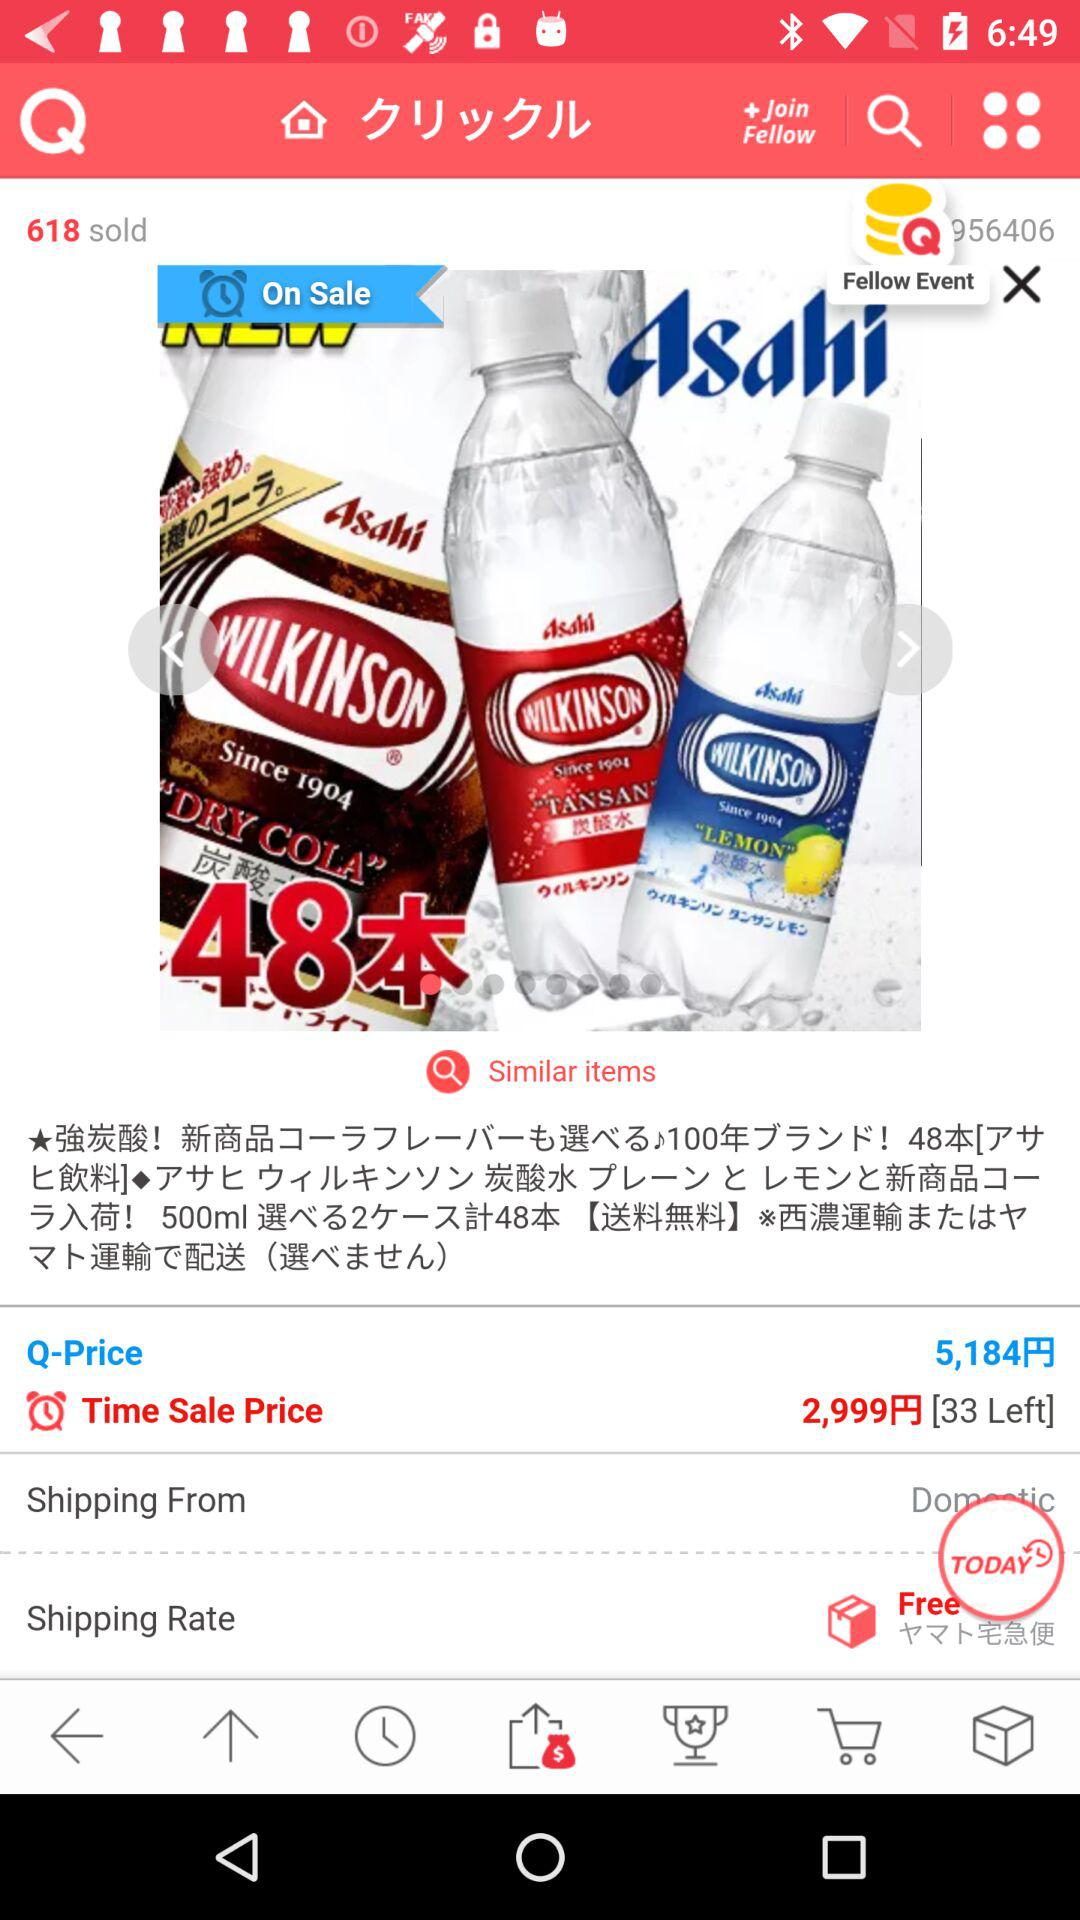How many items are left in stock?
Answer the question using a single word or phrase. 33 